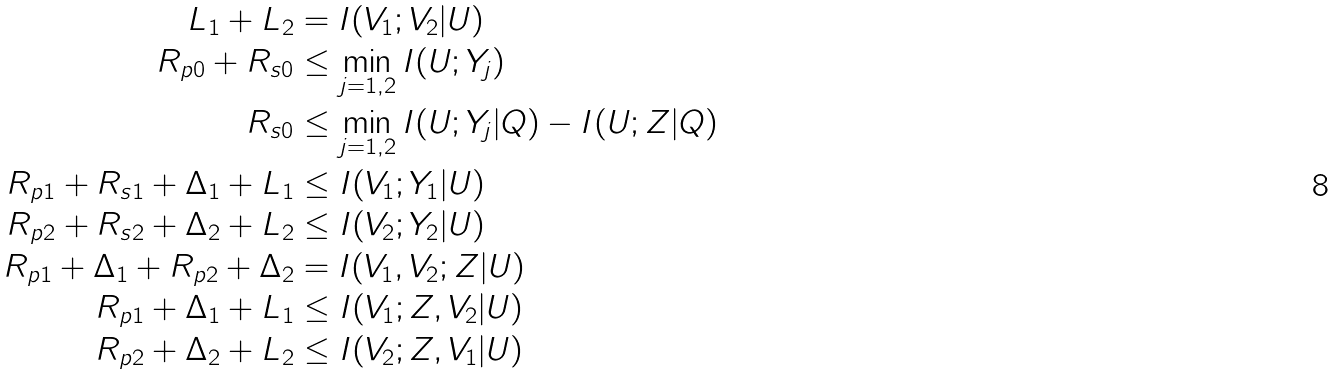Convert formula to latex. <formula><loc_0><loc_0><loc_500><loc_500>L _ { 1 } + L _ { 2 } & = I ( V _ { 1 } ; V _ { 2 } | U ) \\ R _ { p 0 } + R _ { s 0 } & \leq \min _ { j = 1 , 2 } I ( U ; Y _ { j } ) \\ R _ { s 0 } & \leq \min _ { j = 1 , 2 } I ( U ; Y _ { j } | Q ) - I ( U ; Z | Q ) \\ R _ { p 1 } + R _ { s 1 } + \Delta _ { 1 } + L _ { 1 } & \leq I ( V _ { 1 } ; Y _ { 1 } | U ) \\ R _ { p 2 } + R _ { s 2 } + \Delta _ { 2 } + L _ { 2 } & \leq I ( V _ { 2 } ; Y _ { 2 } | U ) \\ R _ { p 1 } + \Delta _ { 1 } + R _ { p 2 } + \Delta _ { 2 } & = I ( V _ { 1 } , V _ { 2 } ; Z | U ) \\ R _ { p 1 } + \Delta _ { 1 } + L _ { 1 } & \leq I ( V _ { 1 } ; Z , V _ { 2 } | U ) \\ R _ { p 2 } + \Delta _ { 2 } + L _ { 2 } & \leq I ( V _ { 2 } ; Z , V _ { 1 } | U ) \\</formula> 